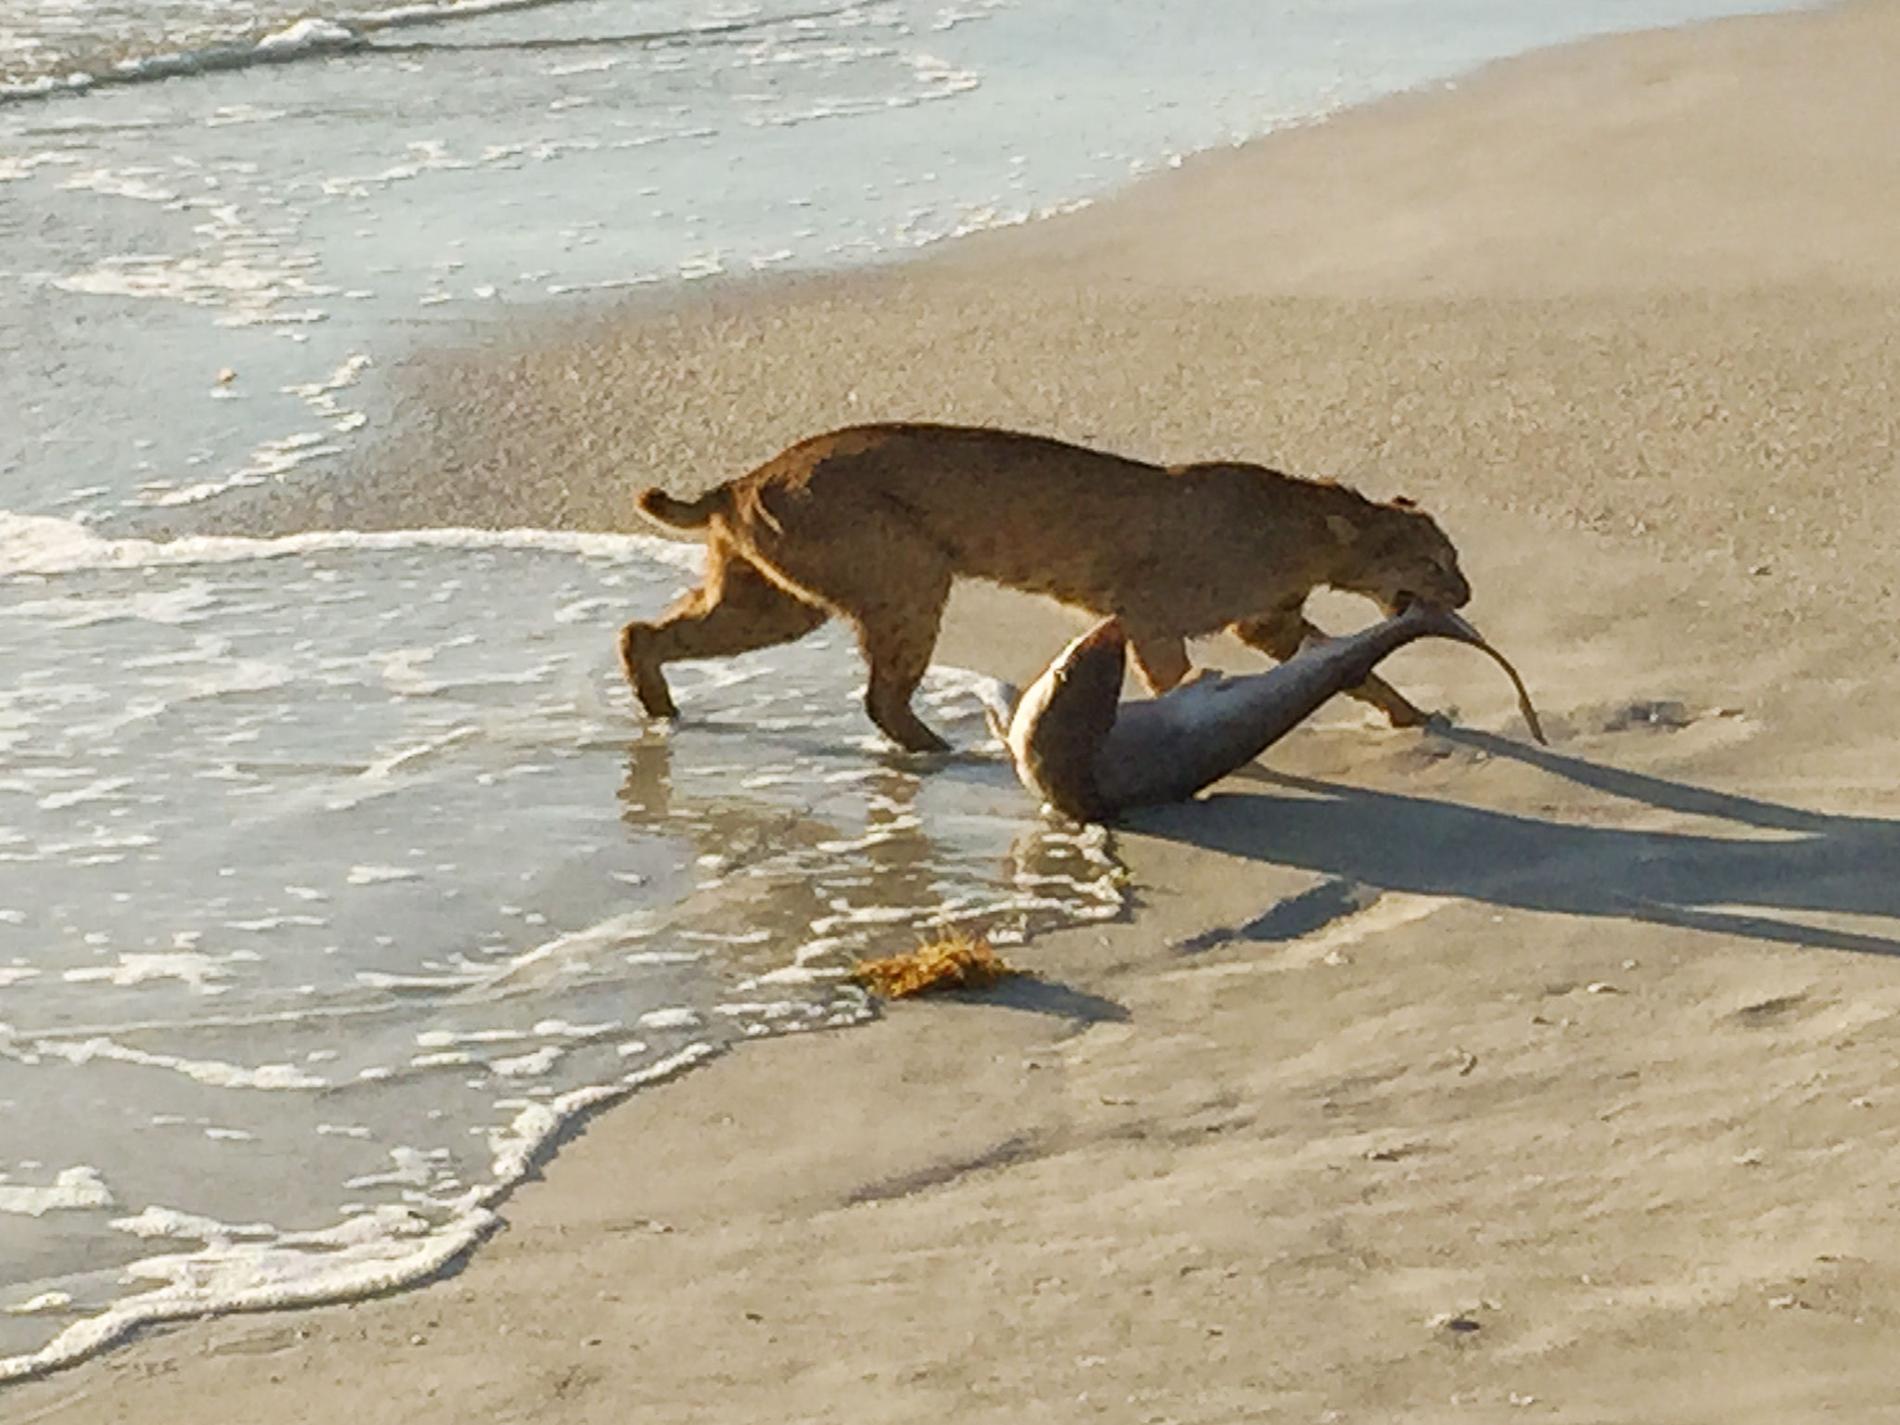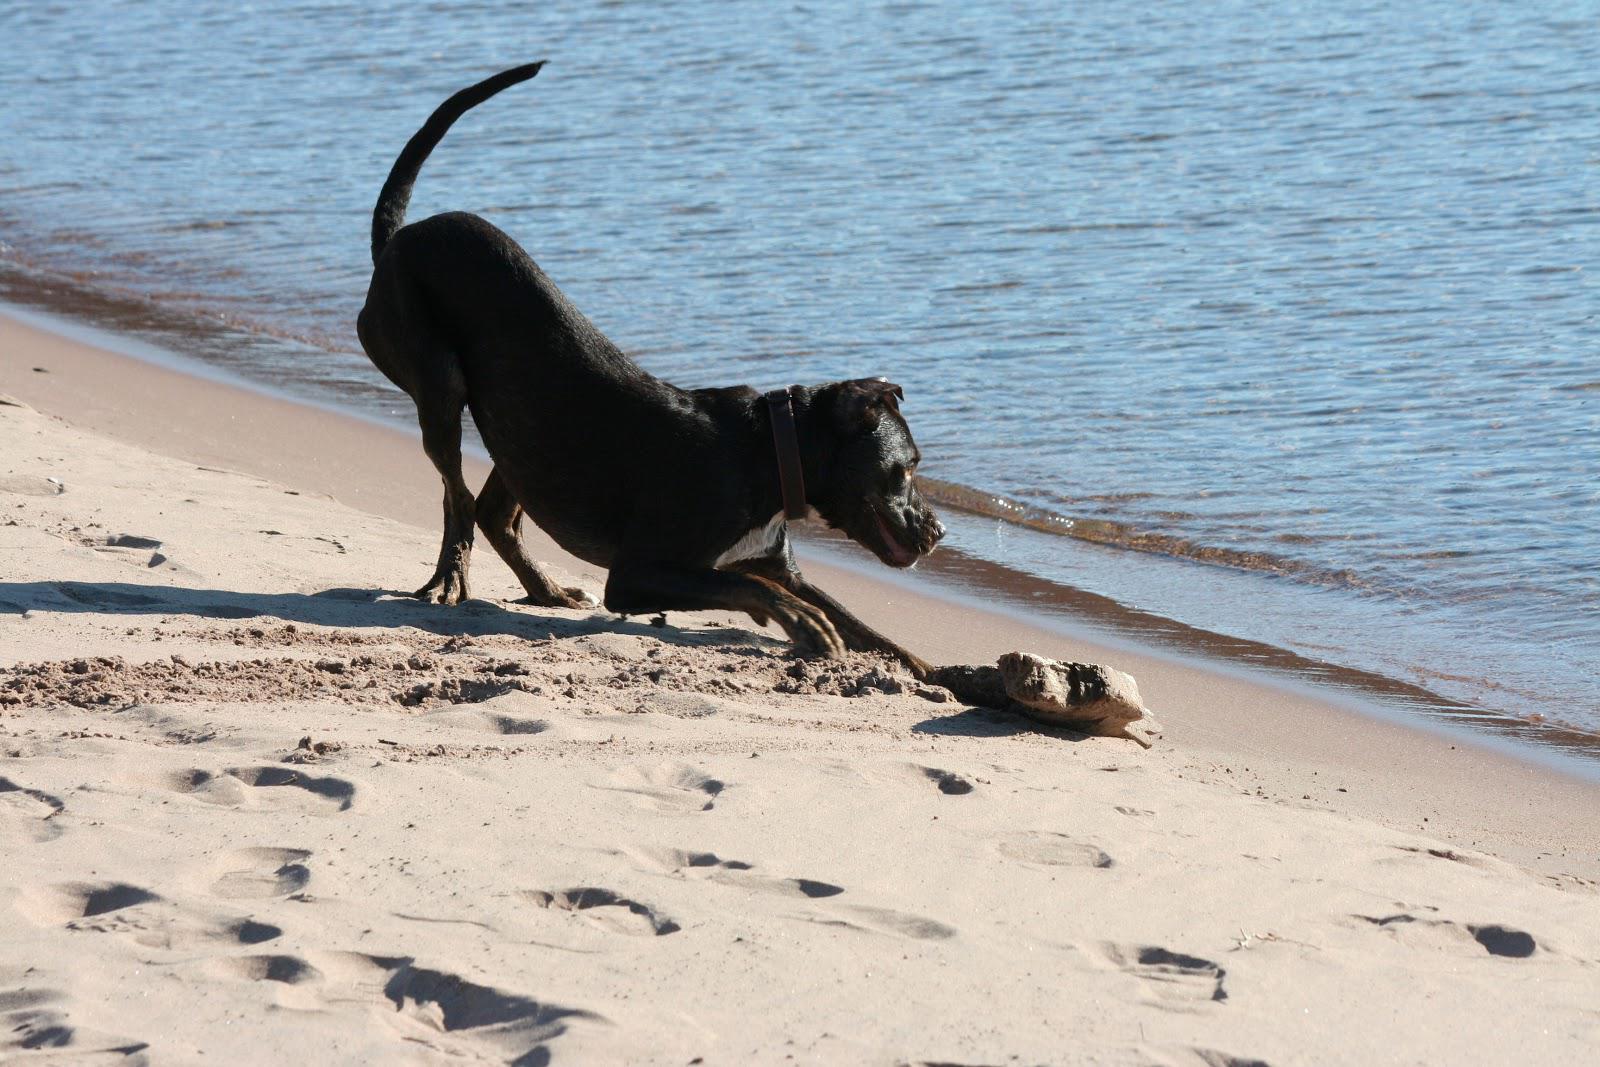The first image is the image on the left, the second image is the image on the right. Assess this claim about the two images: "The front half of one shark is lying in the sand.". Correct or not? Answer yes or no. No. 